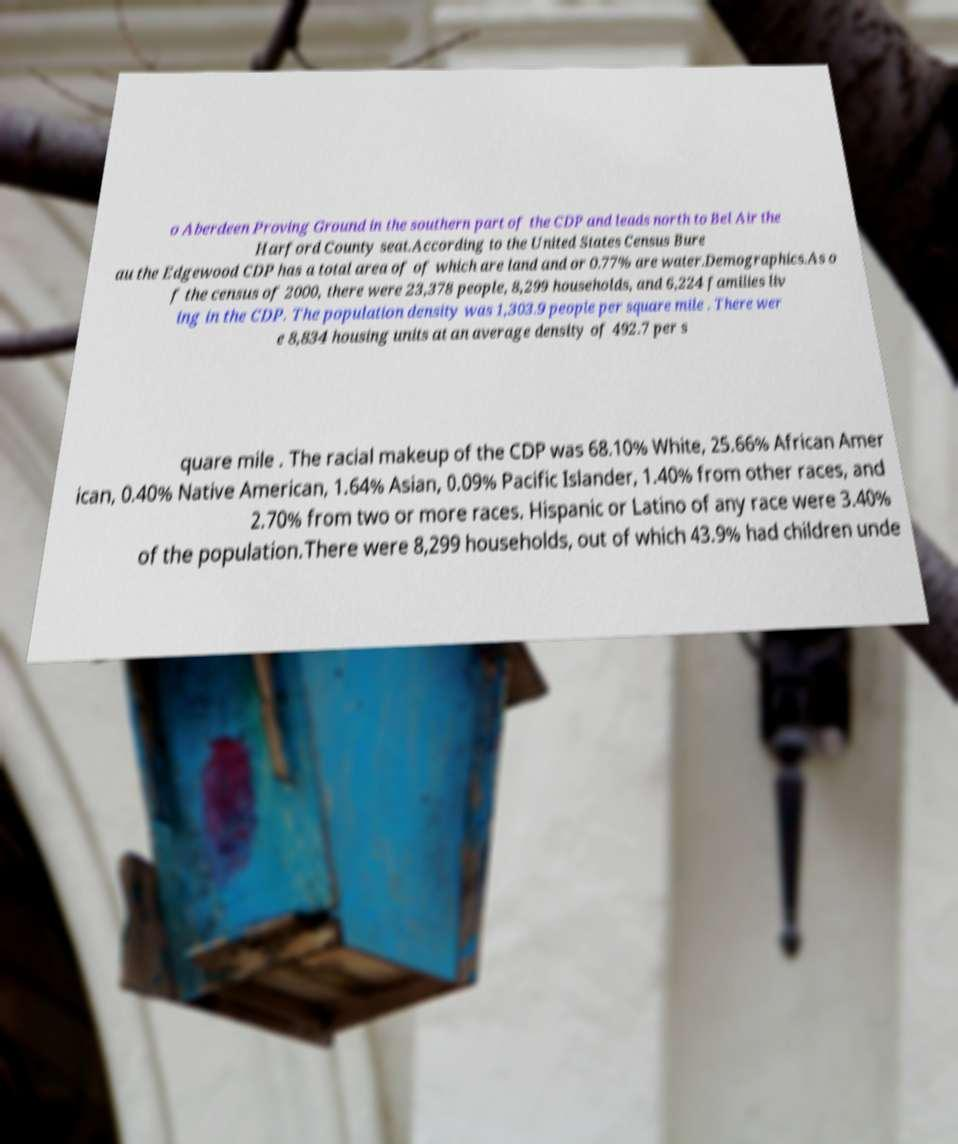Could you extract and type out the text from this image? o Aberdeen Proving Ground in the southern part of the CDP and leads north to Bel Air the Harford County seat.According to the United States Census Bure au the Edgewood CDP has a total area of of which are land and or 0.77% are water.Demographics.As o f the census of 2000, there were 23,378 people, 8,299 households, and 6,224 families liv ing in the CDP. The population density was 1,303.9 people per square mile . There wer e 8,834 housing units at an average density of 492.7 per s quare mile . The racial makeup of the CDP was 68.10% White, 25.66% African Amer ican, 0.40% Native American, 1.64% Asian, 0.09% Pacific Islander, 1.40% from other races, and 2.70% from two or more races. Hispanic or Latino of any race were 3.40% of the population.There were 8,299 households, out of which 43.9% had children unde 